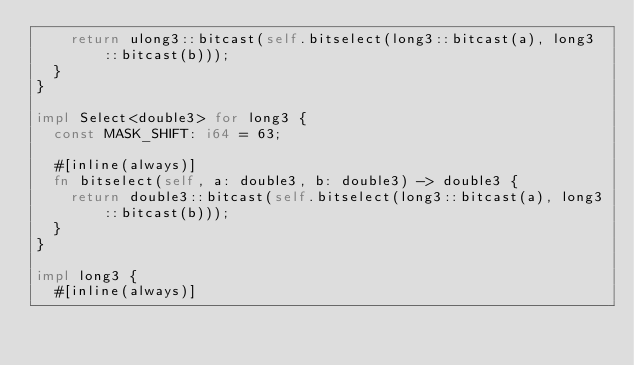<code> <loc_0><loc_0><loc_500><loc_500><_Rust_>    return ulong3::bitcast(self.bitselect(long3::bitcast(a), long3::bitcast(b)));
  }
}

impl Select<double3> for long3 {
  const MASK_SHIFT: i64 = 63;

  #[inline(always)]
  fn bitselect(self, a: double3, b: double3) -> double3 {
    return double3::bitcast(self.bitselect(long3::bitcast(a), long3::bitcast(b)));
  }
}

impl long3 {
  #[inline(always)]</code> 